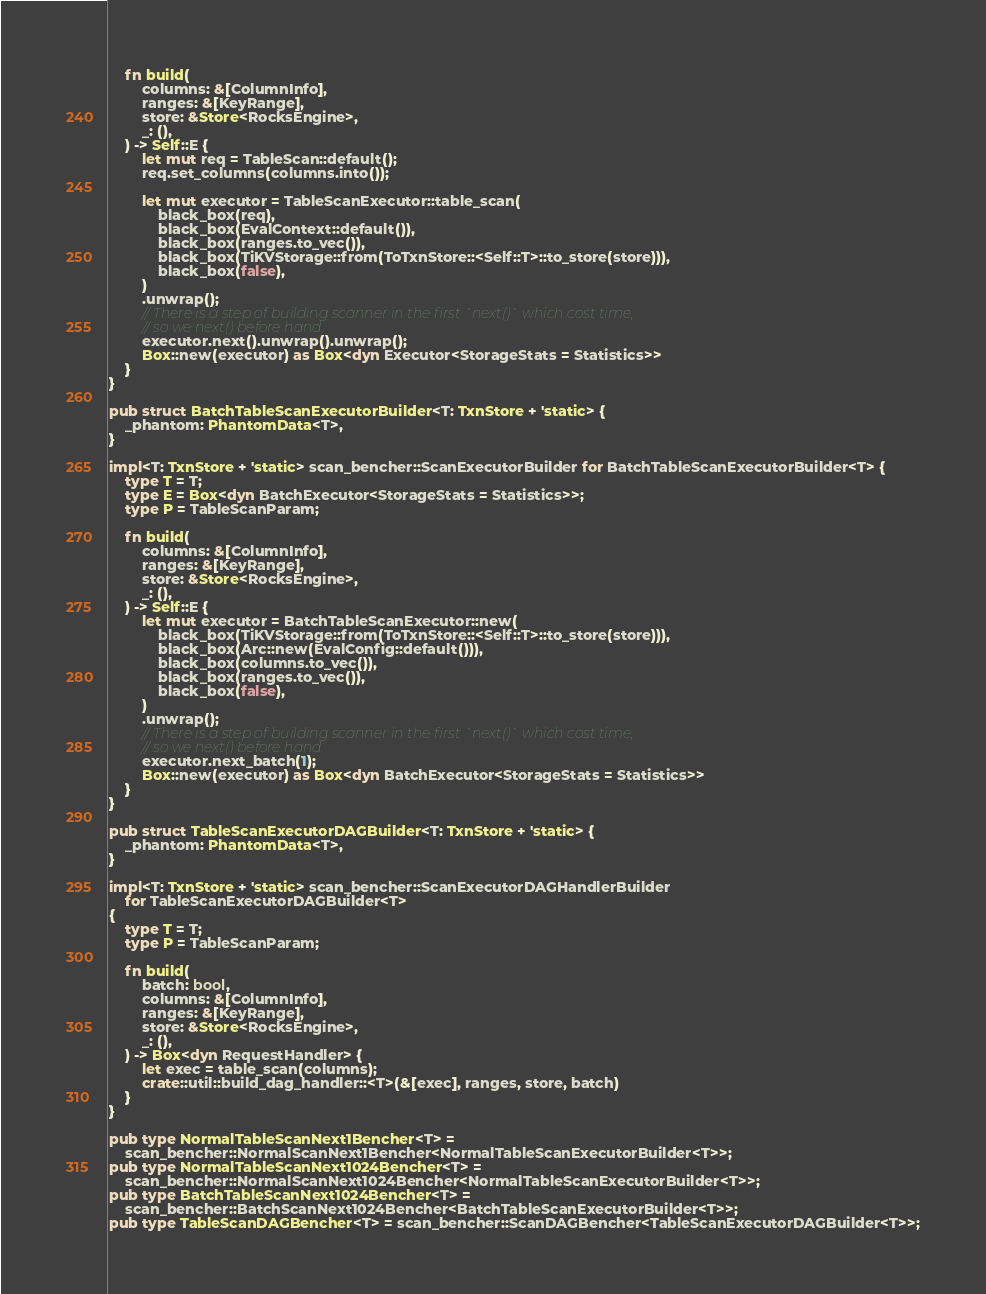Convert code to text. <code><loc_0><loc_0><loc_500><loc_500><_Rust_>
    fn build(
        columns: &[ColumnInfo],
        ranges: &[KeyRange],
        store: &Store<RocksEngine>,
        _: (),
    ) -> Self::E {
        let mut req = TableScan::default();
        req.set_columns(columns.into());

        let mut executor = TableScanExecutor::table_scan(
            black_box(req),
            black_box(EvalContext::default()),
            black_box(ranges.to_vec()),
            black_box(TiKVStorage::from(ToTxnStore::<Self::T>::to_store(store))),
            black_box(false),
        )
        .unwrap();
        // There is a step of building scanner in the first `next()` which cost time,
        // so we next() before hand.
        executor.next().unwrap().unwrap();
        Box::new(executor) as Box<dyn Executor<StorageStats = Statistics>>
    }
}

pub struct BatchTableScanExecutorBuilder<T: TxnStore + 'static> {
    _phantom: PhantomData<T>,
}

impl<T: TxnStore + 'static> scan_bencher::ScanExecutorBuilder for BatchTableScanExecutorBuilder<T> {
    type T = T;
    type E = Box<dyn BatchExecutor<StorageStats = Statistics>>;
    type P = TableScanParam;

    fn build(
        columns: &[ColumnInfo],
        ranges: &[KeyRange],
        store: &Store<RocksEngine>,
        _: (),
    ) -> Self::E {
        let mut executor = BatchTableScanExecutor::new(
            black_box(TiKVStorage::from(ToTxnStore::<Self::T>::to_store(store))),
            black_box(Arc::new(EvalConfig::default())),
            black_box(columns.to_vec()),
            black_box(ranges.to_vec()),
            black_box(false),
        )
        .unwrap();
        // There is a step of building scanner in the first `next()` which cost time,
        // so we next() before hand.
        executor.next_batch(1);
        Box::new(executor) as Box<dyn BatchExecutor<StorageStats = Statistics>>
    }
}

pub struct TableScanExecutorDAGBuilder<T: TxnStore + 'static> {
    _phantom: PhantomData<T>,
}

impl<T: TxnStore + 'static> scan_bencher::ScanExecutorDAGHandlerBuilder
    for TableScanExecutorDAGBuilder<T>
{
    type T = T;
    type P = TableScanParam;

    fn build(
        batch: bool,
        columns: &[ColumnInfo],
        ranges: &[KeyRange],
        store: &Store<RocksEngine>,
        _: (),
    ) -> Box<dyn RequestHandler> {
        let exec = table_scan(columns);
        crate::util::build_dag_handler::<T>(&[exec], ranges, store, batch)
    }
}

pub type NormalTableScanNext1Bencher<T> =
    scan_bencher::NormalScanNext1Bencher<NormalTableScanExecutorBuilder<T>>;
pub type NormalTableScanNext1024Bencher<T> =
    scan_bencher::NormalScanNext1024Bencher<NormalTableScanExecutorBuilder<T>>;
pub type BatchTableScanNext1024Bencher<T> =
    scan_bencher::BatchScanNext1024Bencher<BatchTableScanExecutorBuilder<T>>;
pub type TableScanDAGBencher<T> = scan_bencher::ScanDAGBencher<TableScanExecutorDAGBuilder<T>>;
</code> 